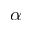Convert formula to latex. <formula><loc_0><loc_0><loc_500><loc_500>\alpha</formula> 